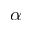Convert formula to latex. <formula><loc_0><loc_0><loc_500><loc_500>\alpha</formula> 